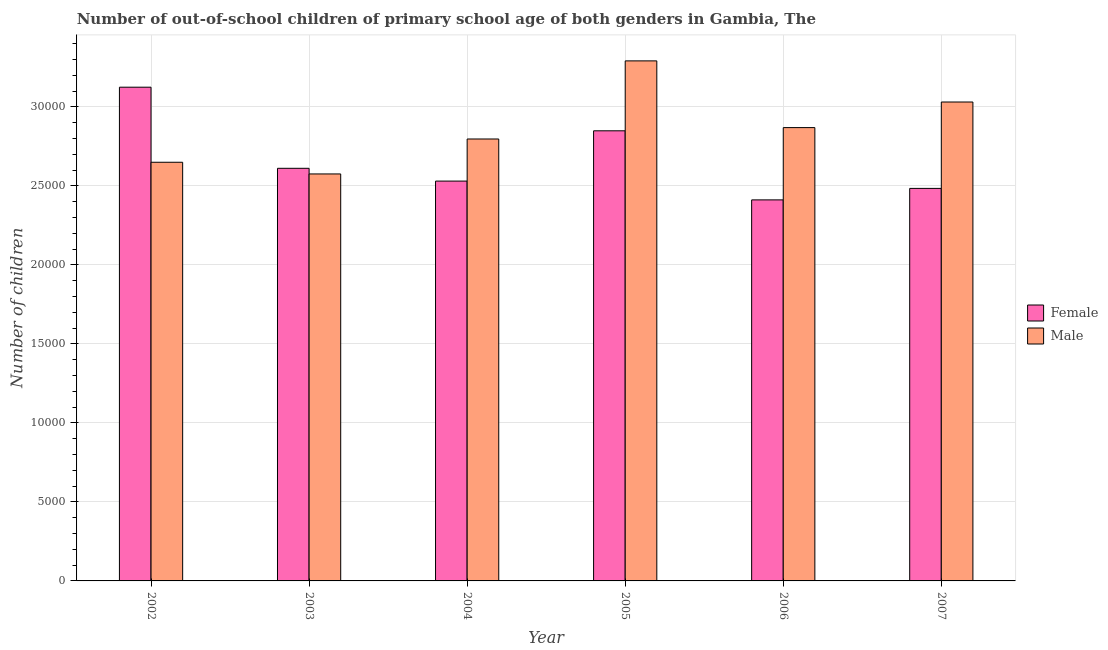How many different coloured bars are there?
Ensure brevity in your answer.  2. How many groups of bars are there?
Offer a terse response. 6. Are the number of bars per tick equal to the number of legend labels?
Give a very brief answer. Yes. Are the number of bars on each tick of the X-axis equal?
Your answer should be very brief. Yes. How many bars are there on the 6th tick from the right?
Give a very brief answer. 2. In how many cases, is the number of bars for a given year not equal to the number of legend labels?
Provide a short and direct response. 0. What is the number of male out-of-school students in 2003?
Provide a succinct answer. 2.58e+04. Across all years, what is the maximum number of male out-of-school students?
Keep it short and to the point. 3.29e+04. Across all years, what is the minimum number of female out-of-school students?
Your answer should be very brief. 2.41e+04. In which year was the number of male out-of-school students maximum?
Offer a terse response. 2005. In which year was the number of male out-of-school students minimum?
Your response must be concise. 2003. What is the total number of female out-of-school students in the graph?
Provide a short and direct response. 1.60e+05. What is the difference between the number of male out-of-school students in 2002 and that in 2004?
Make the answer very short. -1473. What is the difference between the number of male out-of-school students in 2005 and the number of female out-of-school students in 2006?
Make the answer very short. 4223. What is the average number of male out-of-school students per year?
Your answer should be compact. 2.87e+04. What is the ratio of the number of female out-of-school students in 2004 to that in 2007?
Ensure brevity in your answer.  1.02. What is the difference between the highest and the second highest number of female out-of-school students?
Offer a very short reply. 2760. What is the difference between the highest and the lowest number of female out-of-school students?
Offer a very short reply. 7132. Is the sum of the number of female out-of-school students in 2002 and 2004 greater than the maximum number of male out-of-school students across all years?
Your response must be concise. Yes. What does the 2nd bar from the right in 2005 represents?
Give a very brief answer. Female. How many bars are there?
Ensure brevity in your answer.  12. What is the difference between two consecutive major ticks on the Y-axis?
Provide a short and direct response. 5000. Are the values on the major ticks of Y-axis written in scientific E-notation?
Make the answer very short. No. Does the graph contain any zero values?
Your answer should be very brief. No. How many legend labels are there?
Your response must be concise. 2. How are the legend labels stacked?
Your response must be concise. Vertical. What is the title of the graph?
Give a very brief answer. Number of out-of-school children of primary school age of both genders in Gambia, The. What is the label or title of the X-axis?
Your answer should be very brief. Year. What is the label or title of the Y-axis?
Give a very brief answer. Number of children. What is the Number of children in Female in 2002?
Make the answer very short. 3.12e+04. What is the Number of children of Male in 2002?
Make the answer very short. 2.65e+04. What is the Number of children of Female in 2003?
Make the answer very short. 2.61e+04. What is the Number of children in Male in 2003?
Offer a very short reply. 2.58e+04. What is the Number of children of Female in 2004?
Make the answer very short. 2.53e+04. What is the Number of children of Male in 2004?
Your answer should be very brief. 2.80e+04. What is the Number of children in Female in 2005?
Offer a terse response. 2.85e+04. What is the Number of children of Male in 2005?
Make the answer very short. 3.29e+04. What is the Number of children in Female in 2006?
Provide a succinct answer. 2.41e+04. What is the Number of children of Male in 2006?
Offer a terse response. 2.87e+04. What is the Number of children of Female in 2007?
Provide a short and direct response. 2.48e+04. What is the Number of children of Male in 2007?
Provide a short and direct response. 3.03e+04. Across all years, what is the maximum Number of children of Female?
Keep it short and to the point. 3.12e+04. Across all years, what is the maximum Number of children of Male?
Ensure brevity in your answer.  3.29e+04. Across all years, what is the minimum Number of children in Female?
Your answer should be very brief. 2.41e+04. Across all years, what is the minimum Number of children in Male?
Keep it short and to the point. 2.58e+04. What is the total Number of children in Female in the graph?
Give a very brief answer. 1.60e+05. What is the total Number of children of Male in the graph?
Make the answer very short. 1.72e+05. What is the difference between the Number of children in Female in 2002 and that in 2003?
Ensure brevity in your answer.  5134. What is the difference between the Number of children of Male in 2002 and that in 2003?
Offer a very short reply. 740. What is the difference between the Number of children in Female in 2002 and that in 2004?
Provide a succinct answer. 5943. What is the difference between the Number of children of Male in 2002 and that in 2004?
Make the answer very short. -1473. What is the difference between the Number of children of Female in 2002 and that in 2005?
Provide a short and direct response. 2760. What is the difference between the Number of children in Male in 2002 and that in 2005?
Give a very brief answer. -6417. What is the difference between the Number of children of Female in 2002 and that in 2006?
Offer a terse response. 7132. What is the difference between the Number of children in Male in 2002 and that in 2006?
Provide a succinct answer. -2194. What is the difference between the Number of children in Female in 2002 and that in 2007?
Make the answer very short. 6405. What is the difference between the Number of children in Male in 2002 and that in 2007?
Offer a terse response. -3814. What is the difference between the Number of children of Female in 2003 and that in 2004?
Provide a succinct answer. 809. What is the difference between the Number of children in Male in 2003 and that in 2004?
Your answer should be very brief. -2213. What is the difference between the Number of children of Female in 2003 and that in 2005?
Ensure brevity in your answer.  -2374. What is the difference between the Number of children of Male in 2003 and that in 2005?
Provide a short and direct response. -7157. What is the difference between the Number of children of Female in 2003 and that in 2006?
Your answer should be very brief. 1998. What is the difference between the Number of children in Male in 2003 and that in 2006?
Your response must be concise. -2934. What is the difference between the Number of children of Female in 2003 and that in 2007?
Offer a terse response. 1271. What is the difference between the Number of children of Male in 2003 and that in 2007?
Provide a succinct answer. -4554. What is the difference between the Number of children in Female in 2004 and that in 2005?
Your response must be concise. -3183. What is the difference between the Number of children of Male in 2004 and that in 2005?
Keep it short and to the point. -4944. What is the difference between the Number of children of Female in 2004 and that in 2006?
Give a very brief answer. 1189. What is the difference between the Number of children in Male in 2004 and that in 2006?
Make the answer very short. -721. What is the difference between the Number of children of Female in 2004 and that in 2007?
Ensure brevity in your answer.  462. What is the difference between the Number of children in Male in 2004 and that in 2007?
Your answer should be compact. -2341. What is the difference between the Number of children of Female in 2005 and that in 2006?
Ensure brevity in your answer.  4372. What is the difference between the Number of children of Male in 2005 and that in 2006?
Provide a short and direct response. 4223. What is the difference between the Number of children of Female in 2005 and that in 2007?
Offer a very short reply. 3645. What is the difference between the Number of children in Male in 2005 and that in 2007?
Make the answer very short. 2603. What is the difference between the Number of children in Female in 2006 and that in 2007?
Give a very brief answer. -727. What is the difference between the Number of children in Male in 2006 and that in 2007?
Give a very brief answer. -1620. What is the difference between the Number of children in Female in 2002 and the Number of children in Male in 2003?
Your response must be concise. 5491. What is the difference between the Number of children in Female in 2002 and the Number of children in Male in 2004?
Offer a terse response. 3278. What is the difference between the Number of children of Female in 2002 and the Number of children of Male in 2005?
Make the answer very short. -1666. What is the difference between the Number of children of Female in 2002 and the Number of children of Male in 2006?
Offer a very short reply. 2557. What is the difference between the Number of children of Female in 2002 and the Number of children of Male in 2007?
Provide a short and direct response. 937. What is the difference between the Number of children in Female in 2003 and the Number of children in Male in 2004?
Make the answer very short. -1856. What is the difference between the Number of children of Female in 2003 and the Number of children of Male in 2005?
Your answer should be compact. -6800. What is the difference between the Number of children of Female in 2003 and the Number of children of Male in 2006?
Give a very brief answer. -2577. What is the difference between the Number of children of Female in 2003 and the Number of children of Male in 2007?
Offer a terse response. -4197. What is the difference between the Number of children in Female in 2004 and the Number of children in Male in 2005?
Your answer should be very brief. -7609. What is the difference between the Number of children in Female in 2004 and the Number of children in Male in 2006?
Keep it short and to the point. -3386. What is the difference between the Number of children in Female in 2004 and the Number of children in Male in 2007?
Offer a very short reply. -5006. What is the difference between the Number of children of Female in 2005 and the Number of children of Male in 2006?
Your answer should be very brief. -203. What is the difference between the Number of children in Female in 2005 and the Number of children in Male in 2007?
Provide a succinct answer. -1823. What is the difference between the Number of children in Female in 2006 and the Number of children in Male in 2007?
Provide a succinct answer. -6195. What is the average Number of children of Female per year?
Provide a succinct answer. 2.67e+04. What is the average Number of children of Male per year?
Make the answer very short. 2.87e+04. In the year 2002, what is the difference between the Number of children of Female and Number of children of Male?
Keep it short and to the point. 4751. In the year 2003, what is the difference between the Number of children of Female and Number of children of Male?
Provide a succinct answer. 357. In the year 2004, what is the difference between the Number of children in Female and Number of children in Male?
Provide a short and direct response. -2665. In the year 2005, what is the difference between the Number of children of Female and Number of children of Male?
Offer a very short reply. -4426. In the year 2006, what is the difference between the Number of children of Female and Number of children of Male?
Your answer should be very brief. -4575. In the year 2007, what is the difference between the Number of children in Female and Number of children in Male?
Give a very brief answer. -5468. What is the ratio of the Number of children in Female in 2002 to that in 2003?
Make the answer very short. 1.2. What is the ratio of the Number of children in Male in 2002 to that in 2003?
Make the answer very short. 1.03. What is the ratio of the Number of children in Female in 2002 to that in 2004?
Offer a very short reply. 1.23. What is the ratio of the Number of children in Male in 2002 to that in 2004?
Your answer should be compact. 0.95. What is the ratio of the Number of children in Female in 2002 to that in 2005?
Keep it short and to the point. 1.1. What is the ratio of the Number of children in Male in 2002 to that in 2005?
Give a very brief answer. 0.81. What is the ratio of the Number of children of Female in 2002 to that in 2006?
Provide a short and direct response. 1.3. What is the ratio of the Number of children in Male in 2002 to that in 2006?
Make the answer very short. 0.92. What is the ratio of the Number of children in Female in 2002 to that in 2007?
Keep it short and to the point. 1.26. What is the ratio of the Number of children of Male in 2002 to that in 2007?
Make the answer very short. 0.87. What is the ratio of the Number of children in Female in 2003 to that in 2004?
Your response must be concise. 1.03. What is the ratio of the Number of children of Male in 2003 to that in 2004?
Provide a succinct answer. 0.92. What is the ratio of the Number of children of Male in 2003 to that in 2005?
Offer a terse response. 0.78. What is the ratio of the Number of children in Female in 2003 to that in 2006?
Your answer should be compact. 1.08. What is the ratio of the Number of children of Male in 2003 to that in 2006?
Keep it short and to the point. 0.9. What is the ratio of the Number of children of Female in 2003 to that in 2007?
Give a very brief answer. 1.05. What is the ratio of the Number of children of Male in 2003 to that in 2007?
Give a very brief answer. 0.85. What is the ratio of the Number of children in Female in 2004 to that in 2005?
Offer a terse response. 0.89. What is the ratio of the Number of children of Male in 2004 to that in 2005?
Give a very brief answer. 0.85. What is the ratio of the Number of children of Female in 2004 to that in 2006?
Provide a short and direct response. 1.05. What is the ratio of the Number of children of Male in 2004 to that in 2006?
Ensure brevity in your answer.  0.97. What is the ratio of the Number of children of Female in 2004 to that in 2007?
Give a very brief answer. 1.02. What is the ratio of the Number of children in Male in 2004 to that in 2007?
Ensure brevity in your answer.  0.92. What is the ratio of the Number of children of Female in 2005 to that in 2006?
Keep it short and to the point. 1.18. What is the ratio of the Number of children in Male in 2005 to that in 2006?
Give a very brief answer. 1.15. What is the ratio of the Number of children in Female in 2005 to that in 2007?
Offer a terse response. 1.15. What is the ratio of the Number of children of Male in 2005 to that in 2007?
Offer a terse response. 1.09. What is the ratio of the Number of children of Female in 2006 to that in 2007?
Your answer should be very brief. 0.97. What is the ratio of the Number of children of Male in 2006 to that in 2007?
Provide a succinct answer. 0.95. What is the difference between the highest and the second highest Number of children of Female?
Provide a succinct answer. 2760. What is the difference between the highest and the second highest Number of children of Male?
Keep it short and to the point. 2603. What is the difference between the highest and the lowest Number of children in Female?
Make the answer very short. 7132. What is the difference between the highest and the lowest Number of children of Male?
Your answer should be very brief. 7157. 